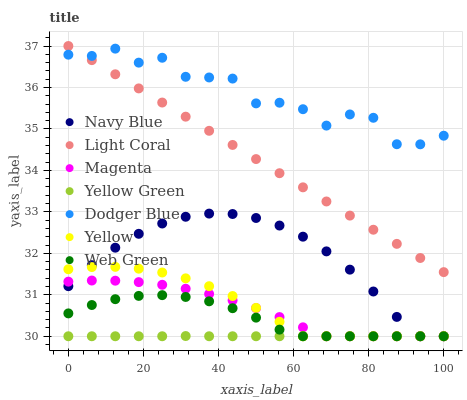Does Yellow Green have the minimum area under the curve?
Answer yes or no. Yes. Does Dodger Blue have the maximum area under the curve?
Answer yes or no. Yes. Does Navy Blue have the minimum area under the curve?
Answer yes or no. No. Does Navy Blue have the maximum area under the curve?
Answer yes or no. No. Is Light Coral the smoothest?
Answer yes or no. Yes. Is Dodger Blue the roughest?
Answer yes or no. Yes. Is Navy Blue the smoothest?
Answer yes or no. No. Is Navy Blue the roughest?
Answer yes or no. No. Does Yellow Green have the lowest value?
Answer yes or no. Yes. Does Light Coral have the lowest value?
Answer yes or no. No. Does Light Coral have the highest value?
Answer yes or no. Yes. Does Navy Blue have the highest value?
Answer yes or no. No. Is Navy Blue less than Dodger Blue?
Answer yes or no. Yes. Is Dodger Blue greater than Yellow?
Answer yes or no. Yes. Does Navy Blue intersect Yellow Green?
Answer yes or no. Yes. Is Navy Blue less than Yellow Green?
Answer yes or no. No. Is Navy Blue greater than Yellow Green?
Answer yes or no. No. Does Navy Blue intersect Dodger Blue?
Answer yes or no. No. 